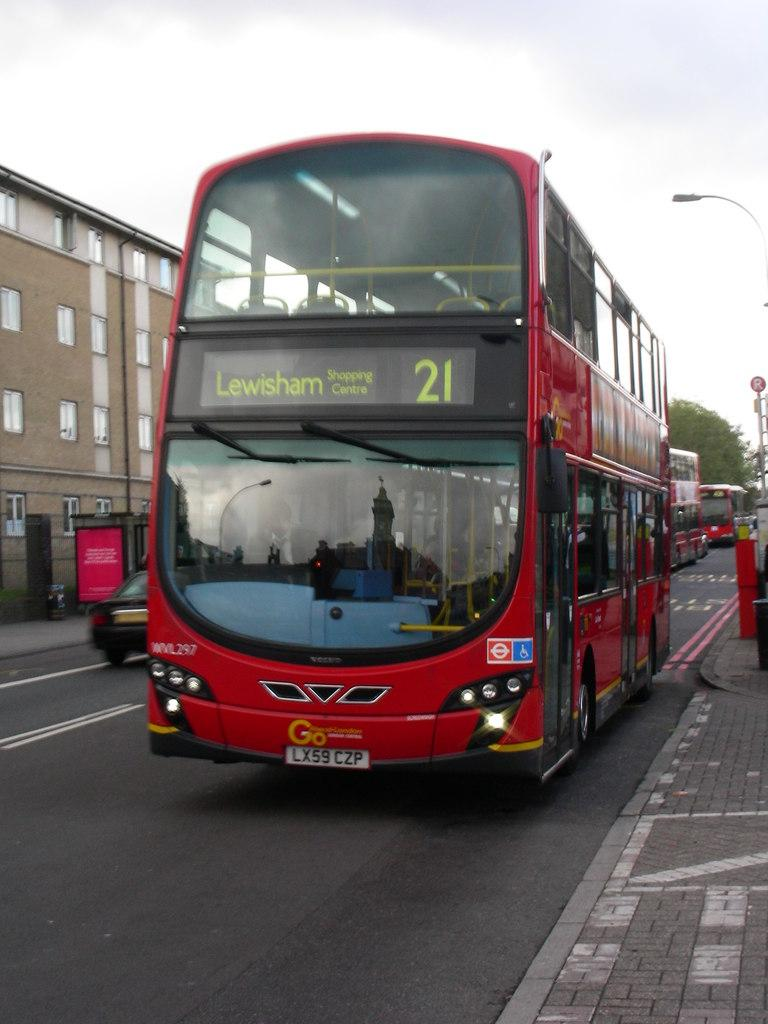<image>
Write a terse but informative summary of the picture. A red double decker bus number 21 going to the Lesisham shopping centre 